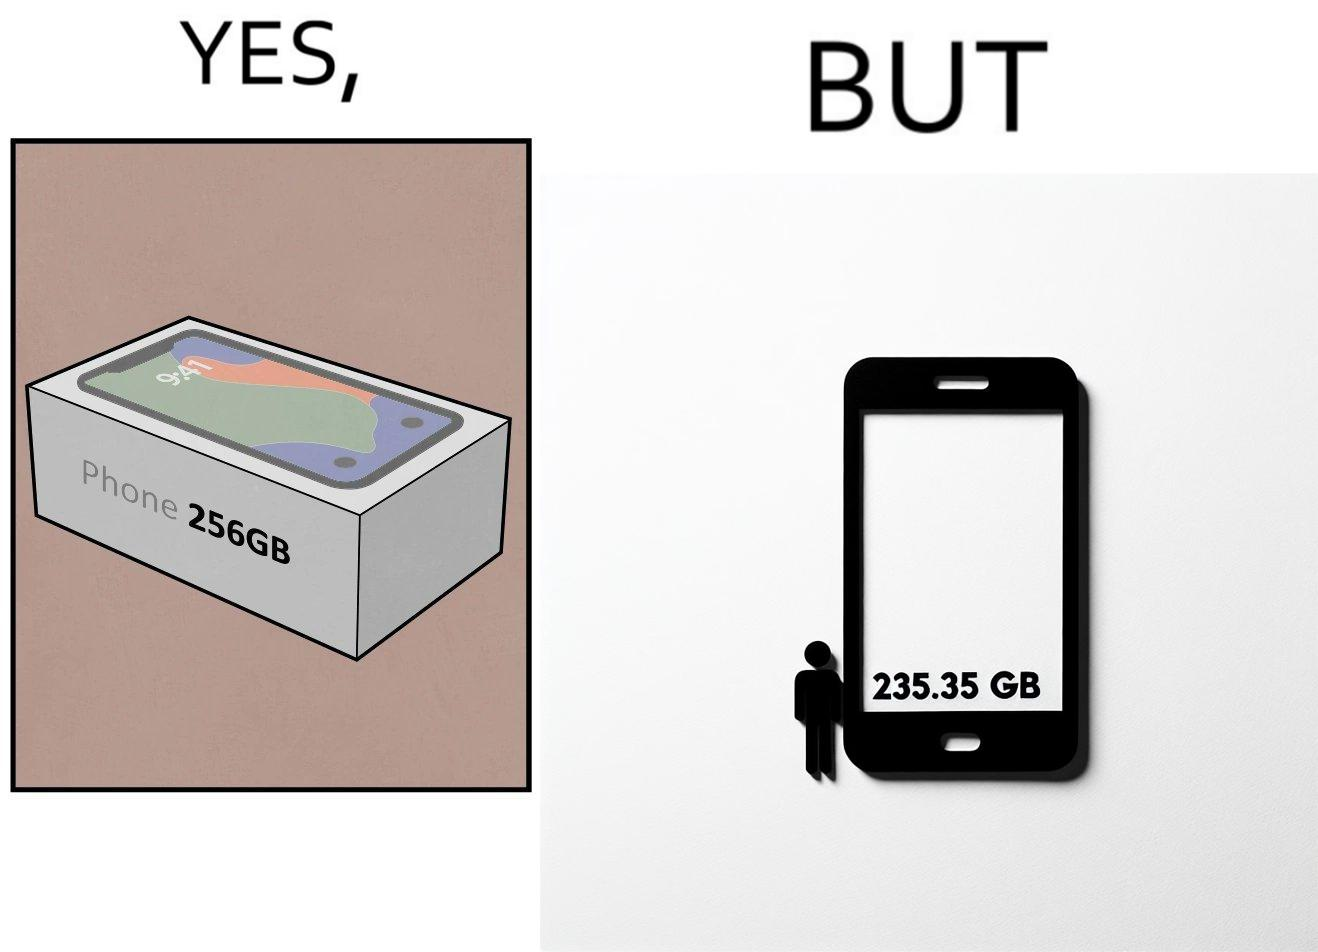Describe the satirical element in this image. The images are funny since they show how smartphone manufacturers advertise their smartphones to have a high internal storage space but in reality, the amount of space available to an user is considerably less due to pre-installed software 